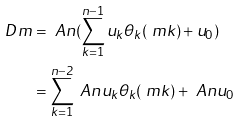Convert formula to latex. <formula><loc_0><loc_0><loc_500><loc_500>D m & = \ A n ( \sum _ { k = 1 } ^ { n - 1 } u _ { k } \theta _ { k } ( \ m k ) + u _ { 0 } ) \\ & = \sum _ { k = 1 } ^ { n - 2 } \ A n u _ { k } \theta _ { k } ( \ m k ) + \ A n u _ { 0 }</formula> 